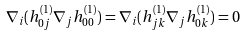Convert formula to latex. <formula><loc_0><loc_0><loc_500><loc_500>\nabla _ { i } ( h ^ { ( 1 ) } _ { 0 j } \nabla _ { j } h _ { 0 0 } ^ { ( 1 ) } ) = \nabla _ { i } ( h ^ { ( 1 ) } _ { j k } \nabla _ { j } h ^ { ( 1 ) } _ { 0 k } ) = 0</formula> 